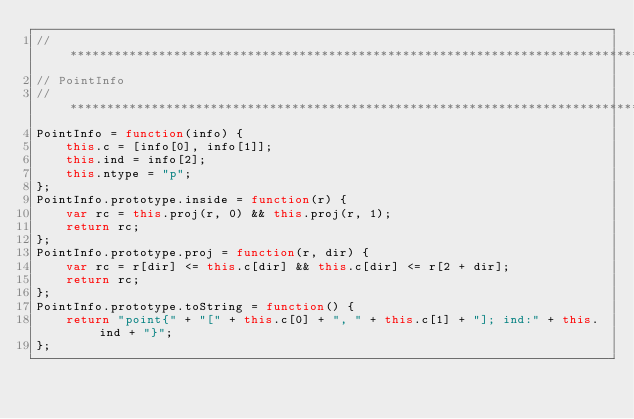<code> <loc_0><loc_0><loc_500><loc_500><_JavaScript_>//******************************************************************************
// PointInfo 
//******************************************************************************
PointInfo = function(info) {
    this.c = [info[0], info[1]];
    this.ind = info[2];
    this.ntype = "p";
};
PointInfo.prototype.inside = function(r) {
    var rc = this.proj(r, 0) && this.proj(r, 1);
    return rc;
};
PointInfo.prototype.proj = function(r, dir) {
    var rc = r[dir] <= this.c[dir] && this.c[dir] <= r[2 + dir];
    return rc;
};
PointInfo.prototype.toString = function() {
    return "point{" + "[" + this.c[0] + ", " + this.c[1] + "]; ind:" + this.ind + "}";
};</code> 